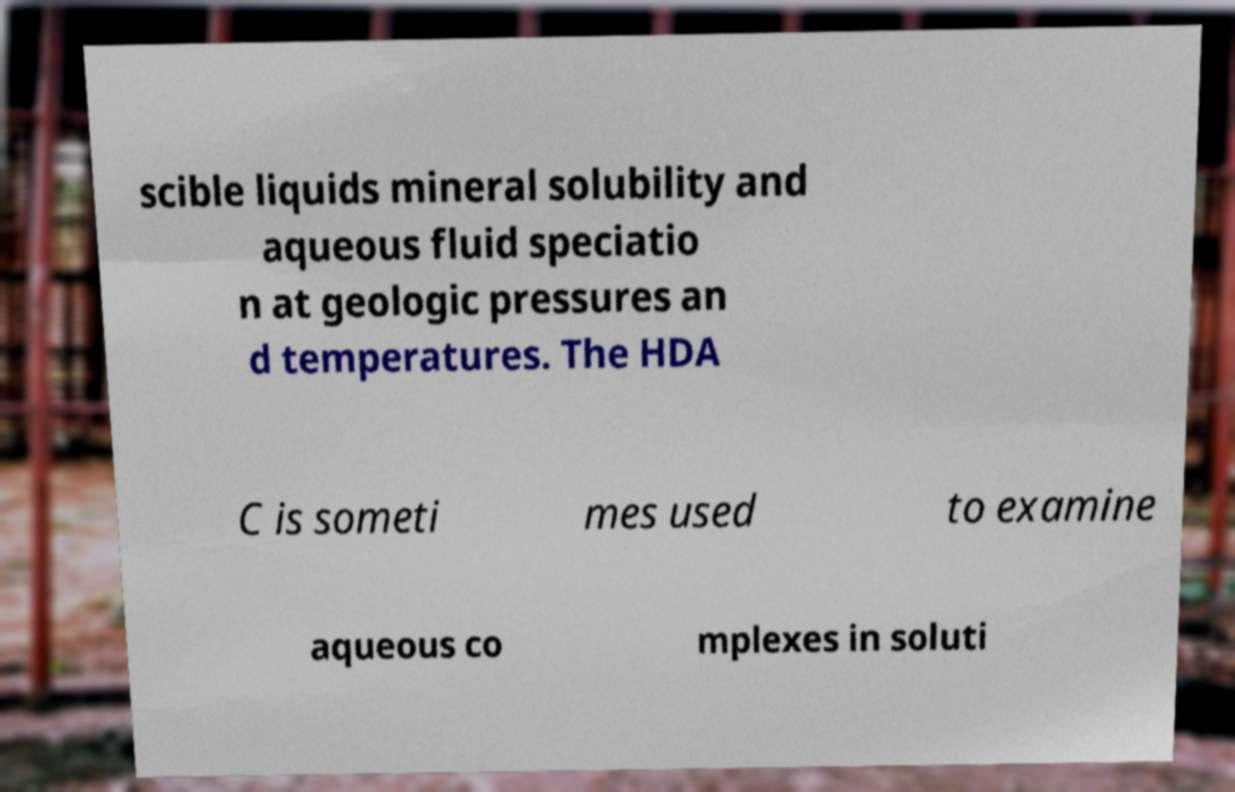Can you read and provide the text displayed in the image?This photo seems to have some interesting text. Can you extract and type it out for me? scible liquids mineral solubility and aqueous fluid speciatio n at geologic pressures an d temperatures. The HDA C is someti mes used to examine aqueous co mplexes in soluti 